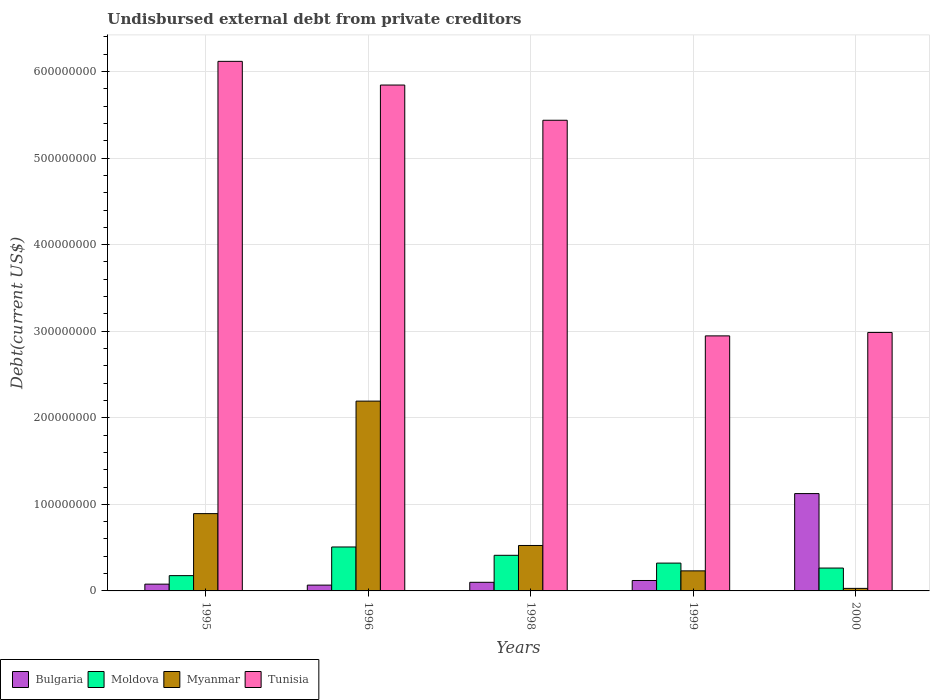How many different coloured bars are there?
Ensure brevity in your answer.  4. Are the number of bars per tick equal to the number of legend labels?
Your answer should be compact. Yes. Are the number of bars on each tick of the X-axis equal?
Make the answer very short. Yes. How many bars are there on the 5th tick from the left?
Give a very brief answer. 4. In how many cases, is the number of bars for a given year not equal to the number of legend labels?
Offer a terse response. 0. What is the total debt in Bulgaria in 1999?
Offer a terse response. 1.20e+07. Across all years, what is the maximum total debt in Tunisia?
Your response must be concise. 6.12e+08. Across all years, what is the minimum total debt in Myanmar?
Provide a short and direct response. 2.94e+06. What is the total total debt in Myanmar in the graph?
Your answer should be compact. 3.87e+08. What is the difference between the total debt in Bulgaria in 1999 and that in 2000?
Give a very brief answer. -1.00e+08. What is the difference between the total debt in Bulgaria in 2000 and the total debt in Moldova in 1999?
Offer a terse response. 8.03e+07. What is the average total debt in Myanmar per year?
Give a very brief answer. 7.74e+07. In the year 1995, what is the difference between the total debt in Tunisia and total debt in Moldova?
Make the answer very short. 5.94e+08. In how many years, is the total debt in Myanmar greater than 320000000 US$?
Your response must be concise. 0. What is the ratio of the total debt in Tunisia in 1999 to that in 2000?
Give a very brief answer. 0.99. Is the total debt in Moldova in 1995 less than that in 1998?
Make the answer very short. Yes. What is the difference between the highest and the second highest total debt in Tunisia?
Provide a succinct answer. 2.74e+07. What is the difference between the highest and the lowest total debt in Bulgaria?
Your answer should be compact. 1.06e+08. In how many years, is the total debt in Bulgaria greater than the average total debt in Bulgaria taken over all years?
Provide a short and direct response. 1. Is the sum of the total debt in Myanmar in 1996 and 2000 greater than the maximum total debt in Bulgaria across all years?
Provide a short and direct response. Yes. What does the 2nd bar from the right in 1995 represents?
Make the answer very short. Myanmar. Is it the case that in every year, the sum of the total debt in Myanmar and total debt in Moldova is greater than the total debt in Tunisia?
Provide a succinct answer. No. Are all the bars in the graph horizontal?
Keep it short and to the point. No. What is the difference between two consecutive major ticks on the Y-axis?
Keep it short and to the point. 1.00e+08. Are the values on the major ticks of Y-axis written in scientific E-notation?
Your response must be concise. No. Does the graph contain grids?
Offer a terse response. Yes. Where does the legend appear in the graph?
Offer a terse response. Bottom left. How are the legend labels stacked?
Your response must be concise. Horizontal. What is the title of the graph?
Provide a short and direct response. Undisbursed external debt from private creditors. What is the label or title of the X-axis?
Your response must be concise. Years. What is the label or title of the Y-axis?
Give a very brief answer. Debt(current US$). What is the Debt(current US$) of Bulgaria in 1995?
Your answer should be compact. 7.82e+06. What is the Debt(current US$) in Moldova in 1995?
Your response must be concise. 1.77e+07. What is the Debt(current US$) of Myanmar in 1995?
Provide a short and direct response. 8.93e+07. What is the Debt(current US$) in Tunisia in 1995?
Offer a very short reply. 6.12e+08. What is the Debt(current US$) of Bulgaria in 1996?
Your response must be concise. 6.71e+06. What is the Debt(current US$) of Moldova in 1996?
Make the answer very short. 5.08e+07. What is the Debt(current US$) in Myanmar in 1996?
Ensure brevity in your answer.  2.19e+08. What is the Debt(current US$) in Tunisia in 1996?
Offer a terse response. 5.84e+08. What is the Debt(current US$) of Bulgaria in 1998?
Provide a short and direct response. 9.95e+06. What is the Debt(current US$) in Moldova in 1998?
Provide a succinct answer. 4.11e+07. What is the Debt(current US$) of Myanmar in 1998?
Your answer should be very brief. 5.25e+07. What is the Debt(current US$) of Tunisia in 1998?
Offer a very short reply. 5.44e+08. What is the Debt(current US$) in Bulgaria in 1999?
Your response must be concise. 1.20e+07. What is the Debt(current US$) of Moldova in 1999?
Make the answer very short. 3.21e+07. What is the Debt(current US$) in Myanmar in 1999?
Offer a very short reply. 2.32e+07. What is the Debt(current US$) in Tunisia in 1999?
Offer a very short reply. 2.95e+08. What is the Debt(current US$) of Bulgaria in 2000?
Give a very brief answer. 1.12e+08. What is the Debt(current US$) of Moldova in 2000?
Your answer should be very brief. 2.64e+07. What is the Debt(current US$) in Myanmar in 2000?
Provide a succinct answer. 2.94e+06. What is the Debt(current US$) in Tunisia in 2000?
Ensure brevity in your answer.  2.99e+08. Across all years, what is the maximum Debt(current US$) of Bulgaria?
Offer a very short reply. 1.12e+08. Across all years, what is the maximum Debt(current US$) of Moldova?
Give a very brief answer. 5.08e+07. Across all years, what is the maximum Debt(current US$) in Myanmar?
Ensure brevity in your answer.  2.19e+08. Across all years, what is the maximum Debt(current US$) in Tunisia?
Offer a very short reply. 6.12e+08. Across all years, what is the minimum Debt(current US$) in Bulgaria?
Offer a very short reply. 6.71e+06. Across all years, what is the minimum Debt(current US$) of Moldova?
Your response must be concise. 1.77e+07. Across all years, what is the minimum Debt(current US$) in Myanmar?
Make the answer very short. 2.94e+06. Across all years, what is the minimum Debt(current US$) of Tunisia?
Your answer should be compact. 2.95e+08. What is the total Debt(current US$) in Bulgaria in the graph?
Your response must be concise. 1.49e+08. What is the total Debt(current US$) in Moldova in the graph?
Provide a succinct answer. 1.68e+08. What is the total Debt(current US$) in Myanmar in the graph?
Keep it short and to the point. 3.87e+08. What is the total Debt(current US$) of Tunisia in the graph?
Provide a short and direct response. 2.33e+09. What is the difference between the Debt(current US$) in Bulgaria in 1995 and that in 1996?
Keep it short and to the point. 1.11e+06. What is the difference between the Debt(current US$) of Moldova in 1995 and that in 1996?
Offer a very short reply. -3.31e+07. What is the difference between the Debt(current US$) in Myanmar in 1995 and that in 1996?
Your response must be concise. -1.30e+08. What is the difference between the Debt(current US$) in Tunisia in 1995 and that in 1996?
Offer a terse response. 2.74e+07. What is the difference between the Debt(current US$) in Bulgaria in 1995 and that in 1998?
Offer a terse response. -2.14e+06. What is the difference between the Debt(current US$) of Moldova in 1995 and that in 1998?
Offer a terse response. -2.35e+07. What is the difference between the Debt(current US$) of Myanmar in 1995 and that in 1998?
Your answer should be very brief. 3.68e+07. What is the difference between the Debt(current US$) in Tunisia in 1995 and that in 1998?
Provide a short and direct response. 6.81e+07. What is the difference between the Debt(current US$) in Bulgaria in 1995 and that in 1999?
Make the answer very short. -4.23e+06. What is the difference between the Debt(current US$) of Moldova in 1995 and that in 1999?
Keep it short and to the point. -1.45e+07. What is the difference between the Debt(current US$) in Myanmar in 1995 and that in 1999?
Offer a terse response. 6.61e+07. What is the difference between the Debt(current US$) in Tunisia in 1995 and that in 1999?
Provide a short and direct response. 3.17e+08. What is the difference between the Debt(current US$) of Bulgaria in 1995 and that in 2000?
Give a very brief answer. -1.05e+08. What is the difference between the Debt(current US$) in Moldova in 1995 and that in 2000?
Your answer should be very brief. -8.75e+06. What is the difference between the Debt(current US$) of Myanmar in 1995 and that in 2000?
Provide a short and direct response. 8.64e+07. What is the difference between the Debt(current US$) in Tunisia in 1995 and that in 2000?
Provide a short and direct response. 3.13e+08. What is the difference between the Debt(current US$) in Bulgaria in 1996 and that in 1998?
Provide a short and direct response. -3.25e+06. What is the difference between the Debt(current US$) of Moldova in 1996 and that in 1998?
Offer a very short reply. 9.63e+06. What is the difference between the Debt(current US$) of Myanmar in 1996 and that in 1998?
Your answer should be very brief. 1.67e+08. What is the difference between the Debt(current US$) in Tunisia in 1996 and that in 1998?
Provide a short and direct response. 4.07e+07. What is the difference between the Debt(current US$) of Bulgaria in 1996 and that in 1999?
Ensure brevity in your answer.  -5.34e+06. What is the difference between the Debt(current US$) in Moldova in 1996 and that in 1999?
Your response must be concise. 1.86e+07. What is the difference between the Debt(current US$) in Myanmar in 1996 and that in 1999?
Your answer should be compact. 1.96e+08. What is the difference between the Debt(current US$) in Tunisia in 1996 and that in 1999?
Offer a very short reply. 2.90e+08. What is the difference between the Debt(current US$) in Bulgaria in 1996 and that in 2000?
Your answer should be compact. -1.06e+08. What is the difference between the Debt(current US$) of Moldova in 1996 and that in 2000?
Your response must be concise. 2.44e+07. What is the difference between the Debt(current US$) of Myanmar in 1996 and that in 2000?
Offer a very short reply. 2.16e+08. What is the difference between the Debt(current US$) of Tunisia in 1996 and that in 2000?
Offer a very short reply. 2.86e+08. What is the difference between the Debt(current US$) in Bulgaria in 1998 and that in 1999?
Offer a very short reply. -2.09e+06. What is the difference between the Debt(current US$) in Moldova in 1998 and that in 1999?
Your answer should be compact. 9.01e+06. What is the difference between the Debt(current US$) of Myanmar in 1998 and that in 1999?
Your answer should be very brief. 2.93e+07. What is the difference between the Debt(current US$) of Tunisia in 1998 and that in 1999?
Provide a succinct answer. 2.49e+08. What is the difference between the Debt(current US$) in Bulgaria in 1998 and that in 2000?
Offer a terse response. -1.02e+08. What is the difference between the Debt(current US$) of Moldova in 1998 and that in 2000?
Offer a terse response. 1.47e+07. What is the difference between the Debt(current US$) in Myanmar in 1998 and that in 2000?
Give a very brief answer. 4.96e+07. What is the difference between the Debt(current US$) in Tunisia in 1998 and that in 2000?
Provide a short and direct response. 2.45e+08. What is the difference between the Debt(current US$) in Bulgaria in 1999 and that in 2000?
Your response must be concise. -1.00e+08. What is the difference between the Debt(current US$) in Moldova in 1999 and that in 2000?
Provide a short and direct response. 5.72e+06. What is the difference between the Debt(current US$) in Myanmar in 1999 and that in 2000?
Keep it short and to the point. 2.02e+07. What is the difference between the Debt(current US$) of Tunisia in 1999 and that in 2000?
Your answer should be very brief. -3.97e+06. What is the difference between the Debt(current US$) of Bulgaria in 1995 and the Debt(current US$) of Moldova in 1996?
Keep it short and to the point. -4.30e+07. What is the difference between the Debt(current US$) in Bulgaria in 1995 and the Debt(current US$) in Myanmar in 1996?
Offer a terse response. -2.11e+08. What is the difference between the Debt(current US$) in Bulgaria in 1995 and the Debt(current US$) in Tunisia in 1996?
Offer a very short reply. -5.77e+08. What is the difference between the Debt(current US$) of Moldova in 1995 and the Debt(current US$) of Myanmar in 1996?
Ensure brevity in your answer.  -2.02e+08. What is the difference between the Debt(current US$) of Moldova in 1995 and the Debt(current US$) of Tunisia in 1996?
Offer a terse response. -5.67e+08. What is the difference between the Debt(current US$) of Myanmar in 1995 and the Debt(current US$) of Tunisia in 1996?
Offer a terse response. -4.95e+08. What is the difference between the Debt(current US$) of Bulgaria in 1995 and the Debt(current US$) of Moldova in 1998?
Your answer should be compact. -3.33e+07. What is the difference between the Debt(current US$) of Bulgaria in 1995 and the Debt(current US$) of Myanmar in 1998?
Give a very brief answer. -4.47e+07. What is the difference between the Debt(current US$) in Bulgaria in 1995 and the Debt(current US$) in Tunisia in 1998?
Your answer should be compact. -5.36e+08. What is the difference between the Debt(current US$) in Moldova in 1995 and the Debt(current US$) in Myanmar in 1998?
Give a very brief answer. -3.48e+07. What is the difference between the Debt(current US$) of Moldova in 1995 and the Debt(current US$) of Tunisia in 1998?
Offer a very short reply. -5.26e+08. What is the difference between the Debt(current US$) in Myanmar in 1995 and the Debt(current US$) in Tunisia in 1998?
Make the answer very short. -4.54e+08. What is the difference between the Debt(current US$) of Bulgaria in 1995 and the Debt(current US$) of Moldova in 1999?
Give a very brief answer. -2.43e+07. What is the difference between the Debt(current US$) in Bulgaria in 1995 and the Debt(current US$) in Myanmar in 1999?
Offer a terse response. -1.53e+07. What is the difference between the Debt(current US$) of Bulgaria in 1995 and the Debt(current US$) of Tunisia in 1999?
Provide a succinct answer. -2.87e+08. What is the difference between the Debt(current US$) in Moldova in 1995 and the Debt(current US$) in Myanmar in 1999?
Keep it short and to the point. -5.50e+06. What is the difference between the Debt(current US$) of Moldova in 1995 and the Debt(current US$) of Tunisia in 1999?
Your response must be concise. -2.77e+08. What is the difference between the Debt(current US$) of Myanmar in 1995 and the Debt(current US$) of Tunisia in 1999?
Ensure brevity in your answer.  -2.05e+08. What is the difference between the Debt(current US$) of Bulgaria in 1995 and the Debt(current US$) of Moldova in 2000?
Your answer should be very brief. -1.86e+07. What is the difference between the Debt(current US$) of Bulgaria in 1995 and the Debt(current US$) of Myanmar in 2000?
Provide a succinct answer. 4.88e+06. What is the difference between the Debt(current US$) of Bulgaria in 1995 and the Debt(current US$) of Tunisia in 2000?
Give a very brief answer. -2.91e+08. What is the difference between the Debt(current US$) in Moldova in 1995 and the Debt(current US$) in Myanmar in 2000?
Provide a short and direct response. 1.47e+07. What is the difference between the Debt(current US$) of Moldova in 1995 and the Debt(current US$) of Tunisia in 2000?
Provide a succinct answer. -2.81e+08. What is the difference between the Debt(current US$) in Myanmar in 1995 and the Debt(current US$) in Tunisia in 2000?
Ensure brevity in your answer.  -2.09e+08. What is the difference between the Debt(current US$) in Bulgaria in 1996 and the Debt(current US$) in Moldova in 1998?
Provide a succinct answer. -3.44e+07. What is the difference between the Debt(current US$) in Bulgaria in 1996 and the Debt(current US$) in Myanmar in 1998?
Keep it short and to the point. -4.58e+07. What is the difference between the Debt(current US$) of Bulgaria in 1996 and the Debt(current US$) of Tunisia in 1998?
Ensure brevity in your answer.  -5.37e+08. What is the difference between the Debt(current US$) of Moldova in 1996 and the Debt(current US$) of Myanmar in 1998?
Provide a short and direct response. -1.72e+06. What is the difference between the Debt(current US$) of Moldova in 1996 and the Debt(current US$) of Tunisia in 1998?
Your answer should be very brief. -4.93e+08. What is the difference between the Debt(current US$) of Myanmar in 1996 and the Debt(current US$) of Tunisia in 1998?
Offer a terse response. -3.24e+08. What is the difference between the Debt(current US$) in Bulgaria in 1996 and the Debt(current US$) in Moldova in 1999?
Your response must be concise. -2.54e+07. What is the difference between the Debt(current US$) in Bulgaria in 1996 and the Debt(current US$) in Myanmar in 1999?
Keep it short and to the point. -1.65e+07. What is the difference between the Debt(current US$) in Bulgaria in 1996 and the Debt(current US$) in Tunisia in 1999?
Ensure brevity in your answer.  -2.88e+08. What is the difference between the Debt(current US$) of Moldova in 1996 and the Debt(current US$) of Myanmar in 1999?
Make the answer very short. 2.76e+07. What is the difference between the Debt(current US$) of Moldova in 1996 and the Debt(current US$) of Tunisia in 1999?
Make the answer very short. -2.44e+08. What is the difference between the Debt(current US$) in Myanmar in 1996 and the Debt(current US$) in Tunisia in 1999?
Provide a short and direct response. -7.54e+07. What is the difference between the Debt(current US$) of Bulgaria in 1996 and the Debt(current US$) of Moldova in 2000?
Offer a terse response. -1.97e+07. What is the difference between the Debt(current US$) of Bulgaria in 1996 and the Debt(current US$) of Myanmar in 2000?
Give a very brief answer. 3.77e+06. What is the difference between the Debt(current US$) of Bulgaria in 1996 and the Debt(current US$) of Tunisia in 2000?
Provide a short and direct response. -2.92e+08. What is the difference between the Debt(current US$) in Moldova in 1996 and the Debt(current US$) in Myanmar in 2000?
Offer a very short reply. 4.78e+07. What is the difference between the Debt(current US$) of Moldova in 1996 and the Debt(current US$) of Tunisia in 2000?
Ensure brevity in your answer.  -2.48e+08. What is the difference between the Debt(current US$) of Myanmar in 1996 and the Debt(current US$) of Tunisia in 2000?
Offer a very short reply. -7.93e+07. What is the difference between the Debt(current US$) in Bulgaria in 1998 and the Debt(current US$) in Moldova in 1999?
Provide a short and direct response. -2.22e+07. What is the difference between the Debt(current US$) of Bulgaria in 1998 and the Debt(current US$) of Myanmar in 1999?
Provide a short and direct response. -1.32e+07. What is the difference between the Debt(current US$) of Bulgaria in 1998 and the Debt(current US$) of Tunisia in 1999?
Your answer should be compact. -2.85e+08. What is the difference between the Debt(current US$) in Moldova in 1998 and the Debt(current US$) in Myanmar in 1999?
Your answer should be very brief. 1.80e+07. What is the difference between the Debt(current US$) of Moldova in 1998 and the Debt(current US$) of Tunisia in 1999?
Your response must be concise. -2.53e+08. What is the difference between the Debt(current US$) of Myanmar in 1998 and the Debt(current US$) of Tunisia in 1999?
Provide a succinct answer. -2.42e+08. What is the difference between the Debt(current US$) of Bulgaria in 1998 and the Debt(current US$) of Moldova in 2000?
Provide a short and direct response. -1.65e+07. What is the difference between the Debt(current US$) of Bulgaria in 1998 and the Debt(current US$) of Myanmar in 2000?
Your answer should be very brief. 7.01e+06. What is the difference between the Debt(current US$) in Bulgaria in 1998 and the Debt(current US$) in Tunisia in 2000?
Ensure brevity in your answer.  -2.89e+08. What is the difference between the Debt(current US$) of Moldova in 1998 and the Debt(current US$) of Myanmar in 2000?
Ensure brevity in your answer.  3.82e+07. What is the difference between the Debt(current US$) in Moldova in 1998 and the Debt(current US$) in Tunisia in 2000?
Make the answer very short. -2.57e+08. What is the difference between the Debt(current US$) of Myanmar in 1998 and the Debt(current US$) of Tunisia in 2000?
Your response must be concise. -2.46e+08. What is the difference between the Debt(current US$) in Bulgaria in 1999 and the Debt(current US$) in Moldova in 2000?
Make the answer very short. -1.44e+07. What is the difference between the Debt(current US$) in Bulgaria in 1999 and the Debt(current US$) in Myanmar in 2000?
Make the answer very short. 9.11e+06. What is the difference between the Debt(current US$) in Bulgaria in 1999 and the Debt(current US$) in Tunisia in 2000?
Provide a succinct answer. -2.87e+08. What is the difference between the Debt(current US$) in Moldova in 1999 and the Debt(current US$) in Myanmar in 2000?
Your response must be concise. 2.92e+07. What is the difference between the Debt(current US$) of Moldova in 1999 and the Debt(current US$) of Tunisia in 2000?
Offer a very short reply. -2.66e+08. What is the difference between the Debt(current US$) of Myanmar in 1999 and the Debt(current US$) of Tunisia in 2000?
Your answer should be very brief. -2.75e+08. What is the average Debt(current US$) of Bulgaria per year?
Make the answer very short. 2.98e+07. What is the average Debt(current US$) of Moldova per year?
Offer a very short reply. 3.36e+07. What is the average Debt(current US$) of Myanmar per year?
Offer a terse response. 7.74e+07. What is the average Debt(current US$) in Tunisia per year?
Keep it short and to the point. 4.67e+08. In the year 1995, what is the difference between the Debt(current US$) in Bulgaria and Debt(current US$) in Moldova?
Your answer should be very brief. -9.85e+06. In the year 1995, what is the difference between the Debt(current US$) in Bulgaria and Debt(current US$) in Myanmar?
Give a very brief answer. -8.15e+07. In the year 1995, what is the difference between the Debt(current US$) in Bulgaria and Debt(current US$) in Tunisia?
Provide a succinct answer. -6.04e+08. In the year 1995, what is the difference between the Debt(current US$) in Moldova and Debt(current US$) in Myanmar?
Your answer should be compact. -7.16e+07. In the year 1995, what is the difference between the Debt(current US$) of Moldova and Debt(current US$) of Tunisia?
Provide a short and direct response. -5.94e+08. In the year 1995, what is the difference between the Debt(current US$) in Myanmar and Debt(current US$) in Tunisia?
Give a very brief answer. -5.22e+08. In the year 1996, what is the difference between the Debt(current US$) in Bulgaria and Debt(current US$) in Moldova?
Provide a succinct answer. -4.41e+07. In the year 1996, what is the difference between the Debt(current US$) in Bulgaria and Debt(current US$) in Myanmar?
Give a very brief answer. -2.13e+08. In the year 1996, what is the difference between the Debt(current US$) in Bulgaria and Debt(current US$) in Tunisia?
Make the answer very short. -5.78e+08. In the year 1996, what is the difference between the Debt(current US$) of Moldova and Debt(current US$) of Myanmar?
Make the answer very short. -1.68e+08. In the year 1996, what is the difference between the Debt(current US$) of Moldova and Debt(current US$) of Tunisia?
Provide a succinct answer. -5.34e+08. In the year 1996, what is the difference between the Debt(current US$) in Myanmar and Debt(current US$) in Tunisia?
Make the answer very short. -3.65e+08. In the year 1998, what is the difference between the Debt(current US$) of Bulgaria and Debt(current US$) of Moldova?
Make the answer very short. -3.12e+07. In the year 1998, what is the difference between the Debt(current US$) of Bulgaria and Debt(current US$) of Myanmar?
Provide a succinct answer. -4.25e+07. In the year 1998, what is the difference between the Debt(current US$) in Bulgaria and Debt(current US$) in Tunisia?
Your response must be concise. -5.34e+08. In the year 1998, what is the difference between the Debt(current US$) of Moldova and Debt(current US$) of Myanmar?
Your answer should be very brief. -1.14e+07. In the year 1998, what is the difference between the Debt(current US$) in Moldova and Debt(current US$) in Tunisia?
Provide a short and direct response. -5.03e+08. In the year 1998, what is the difference between the Debt(current US$) of Myanmar and Debt(current US$) of Tunisia?
Ensure brevity in your answer.  -4.91e+08. In the year 1999, what is the difference between the Debt(current US$) in Bulgaria and Debt(current US$) in Moldova?
Offer a very short reply. -2.01e+07. In the year 1999, what is the difference between the Debt(current US$) in Bulgaria and Debt(current US$) in Myanmar?
Give a very brief answer. -1.11e+07. In the year 1999, what is the difference between the Debt(current US$) of Bulgaria and Debt(current US$) of Tunisia?
Ensure brevity in your answer.  -2.83e+08. In the year 1999, what is the difference between the Debt(current US$) of Moldova and Debt(current US$) of Myanmar?
Ensure brevity in your answer.  8.97e+06. In the year 1999, what is the difference between the Debt(current US$) in Moldova and Debt(current US$) in Tunisia?
Provide a succinct answer. -2.62e+08. In the year 1999, what is the difference between the Debt(current US$) in Myanmar and Debt(current US$) in Tunisia?
Offer a terse response. -2.71e+08. In the year 2000, what is the difference between the Debt(current US$) in Bulgaria and Debt(current US$) in Moldova?
Ensure brevity in your answer.  8.60e+07. In the year 2000, what is the difference between the Debt(current US$) in Bulgaria and Debt(current US$) in Myanmar?
Your answer should be compact. 1.10e+08. In the year 2000, what is the difference between the Debt(current US$) in Bulgaria and Debt(current US$) in Tunisia?
Keep it short and to the point. -1.86e+08. In the year 2000, what is the difference between the Debt(current US$) in Moldova and Debt(current US$) in Myanmar?
Provide a succinct answer. 2.35e+07. In the year 2000, what is the difference between the Debt(current US$) of Moldova and Debt(current US$) of Tunisia?
Your answer should be very brief. -2.72e+08. In the year 2000, what is the difference between the Debt(current US$) of Myanmar and Debt(current US$) of Tunisia?
Offer a terse response. -2.96e+08. What is the ratio of the Debt(current US$) in Bulgaria in 1995 to that in 1996?
Provide a short and direct response. 1.17. What is the ratio of the Debt(current US$) of Moldova in 1995 to that in 1996?
Offer a very short reply. 0.35. What is the ratio of the Debt(current US$) of Myanmar in 1995 to that in 1996?
Your answer should be compact. 0.41. What is the ratio of the Debt(current US$) of Tunisia in 1995 to that in 1996?
Make the answer very short. 1.05. What is the ratio of the Debt(current US$) of Bulgaria in 1995 to that in 1998?
Your answer should be very brief. 0.79. What is the ratio of the Debt(current US$) of Moldova in 1995 to that in 1998?
Give a very brief answer. 0.43. What is the ratio of the Debt(current US$) in Myanmar in 1995 to that in 1998?
Provide a short and direct response. 1.7. What is the ratio of the Debt(current US$) of Tunisia in 1995 to that in 1998?
Your answer should be very brief. 1.13. What is the ratio of the Debt(current US$) in Bulgaria in 1995 to that in 1999?
Keep it short and to the point. 0.65. What is the ratio of the Debt(current US$) in Moldova in 1995 to that in 1999?
Provide a succinct answer. 0.55. What is the ratio of the Debt(current US$) of Myanmar in 1995 to that in 1999?
Offer a terse response. 3.86. What is the ratio of the Debt(current US$) in Tunisia in 1995 to that in 1999?
Give a very brief answer. 2.08. What is the ratio of the Debt(current US$) in Bulgaria in 1995 to that in 2000?
Keep it short and to the point. 0.07. What is the ratio of the Debt(current US$) of Moldova in 1995 to that in 2000?
Your answer should be very brief. 0.67. What is the ratio of the Debt(current US$) in Myanmar in 1995 to that in 2000?
Provide a short and direct response. 30.38. What is the ratio of the Debt(current US$) of Tunisia in 1995 to that in 2000?
Provide a succinct answer. 2.05. What is the ratio of the Debt(current US$) in Bulgaria in 1996 to that in 1998?
Provide a short and direct response. 0.67. What is the ratio of the Debt(current US$) in Moldova in 1996 to that in 1998?
Keep it short and to the point. 1.23. What is the ratio of the Debt(current US$) of Myanmar in 1996 to that in 1998?
Keep it short and to the point. 4.18. What is the ratio of the Debt(current US$) in Tunisia in 1996 to that in 1998?
Your answer should be very brief. 1.07. What is the ratio of the Debt(current US$) of Bulgaria in 1996 to that in 1999?
Offer a terse response. 0.56. What is the ratio of the Debt(current US$) in Moldova in 1996 to that in 1999?
Offer a very short reply. 1.58. What is the ratio of the Debt(current US$) in Myanmar in 1996 to that in 1999?
Keep it short and to the point. 9.47. What is the ratio of the Debt(current US$) in Tunisia in 1996 to that in 1999?
Provide a short and direct response. 1.98. What is the ratio of the Debt(current US$) of Bulgaria in 1996 to that in 2000?
Give a very brief answer. 0.06. What is the ratio of the Debt(current US$) of Moldova in 1996 to that in 2000?
Provide a succinct answer. 1.92. What is the ratio of the Debt(current US$) in Myanmar in 1996 to that in 2000?
Offer a terse response. 74.61. What is the ratio of the Debt(current US$) in Tunisia in 1996 to that in 2000?
Provide a succinct answer. 1.96. What is the ratio of the Debt(current US$) of Bulgaria in 1998 to that in 1999?
Provide a short and direct response. 0.83. What is the ratio of the Debt(current US$) in Moldova in 1998 to that in 1999?
Your answer should be very brief. 1.28. What is the ratio of the Debt(current US$) of Myanmar in 1998 to that in 1999?
Offer a very short reply. 2.27. What is the ratio of the Debt(current US$) in Tunisia in 1998 to that in 1999?
Provide a short and direct response. 1.85. What is the ratio of the Debt(current US$) of Bulgaria in 1998 to that in 2000?
Provide a succinct answer. 0.09. What is the ratio of the Debt(current US$) of Moldova in 1998 to that in 2000?
Your answer should be very brief. 1.56. What is the ratio of the Debt(current US$) in Myanmar in 1998 to that in 2000?
Provide a succinct answer. 17.86. What is the ratio of the Debt(current US$) of Tunisia in 1998 to that in 2000?
Provide a short and direct response. 1.82. What is the ratio of the Debt(current US$) in Bulgaria in 1999 to that in 2000?
Make the answer very short. 0.11. What is the ratio of the Debt(current US$) of Moldova in 1999 to that in 2000?
Your answer should be very brief. 1.22. What is the ratio of the Debt(current US$) of Myanmar in 1999 to that in 2000?
Keep it short and to the point. 7.88. What is the ratio of the Debt(current US$) in Tunisia in 1999 to that in 2000?
Make the answer very short. 0.99. What is the difference between the highest and the second highest Debt(current US$) in Bulgaria?
Your answer should be very brief. 1.00e+08. What is the difference between the highest and the second highest Debt(current US$) of Moldova?
Give a very brief answer. 9.63e+06. What is the difference between the highest and the second highest Debt(current US$) of Myanmar?
Keep it short and to the point. 1.30e+08. What is the difference between the highest and the second highest Debt(current US$) of Tunisia?
Give a very brief answer. 2.74e+07. What is the difference between the highest and the lowest Debt(current US$) of Bulgaria?
Provide a short and direct response. 1.06e+08. What is the difference between the highest and the lowest Debt(current US$) in Moldova?
Make the answer very short. 3.31e+07. What is the difference between the highest and the lowest Debt(current US$) in Myanmar?
Offer a very short reply. 2.16e+08. What is the difference between the highest and the lowest Debt(current US$) of Tunisia?
Keep it short and to the point. 3.17e+08. 